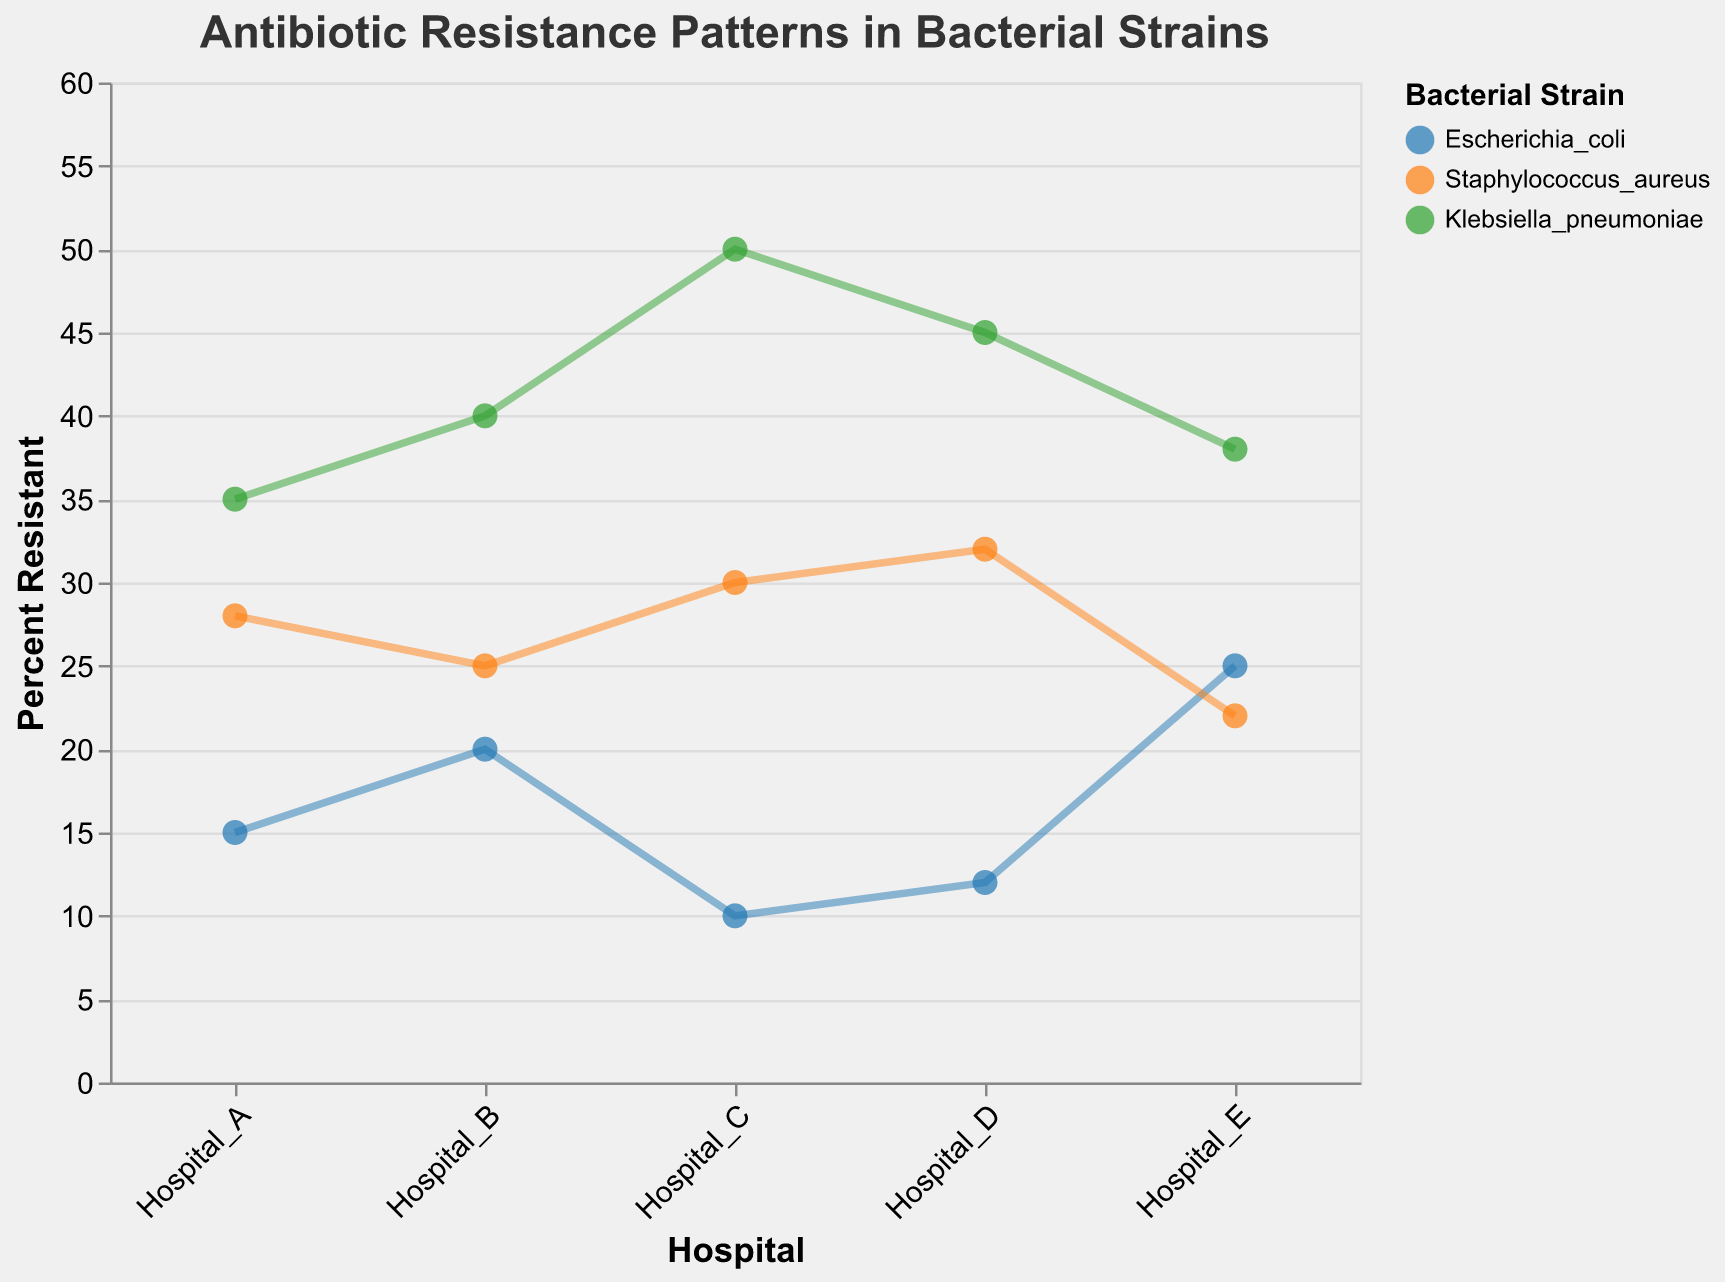What is the title of the figure? The title is displayed at the top of the figure in a larger font.
Answer: Antibiotic Resistance Patterns in Bacterial Strains Which hospital has the highest percent resistant value for Escherichia coli? Check the y-axis values for Escherichia coli data points across all hospitals and identify the highest one.
Answer: Hospital_E Which bacterial strain has the highest overall percent resistant value? Compare the highest percent resistant value of each bacterial strain by looking at the y-axis.
Answer: Klebsiella pneumoniae What is the range of percent resistant values for Staphylococcus aureus across all hospitals? Identify the minimum and maximum percent resistant values for Staphylococcus aureus from the y-axis.
Answer: 22 to 32 Which hospital has the lowest percent resistant value for Klebsiella pneumoniae? Check the y-axis values for Klebsiella pneumoniae data points across all hospitals and identify the lowest one.
Answer: Hospital_A How does the trend line for Escherichia coli compare to Staphylococcus aureus? Observe the slopes of the trend lines. A steeper slope indicates a stronger trend.
Answer: Escherichia coli has a less steep trend line than Staphylococcus aureus What is the difference in percent resistance between Hospital_B and Hospital_C for Staphylococcus aureus? Look at the y-axis values for Staphylococcus aureus in Hospital_B and Hospital_C, then subtract the former from the latter.
Answer: 5 Is there a positive or negative trend between percent resistance and hospital for Klebsiella pneumoniae? Observe the direction of the trend line for Klebsiella pneumoniae data points.
Answer: Positive What is the percent resistant value for Escherichia coli in Hospital_C? Locate the specific data point for Hospital_C and Escherichia coli on the scatter plot, and read the y-axis value.
Answer: 10 How many hospitals have a percent resistant value of 30 or above for Staphylococcus aureus? Count the number of data points for Staphylococcus aureus that have a y-axis value of 30 or above.
Answer: 2 